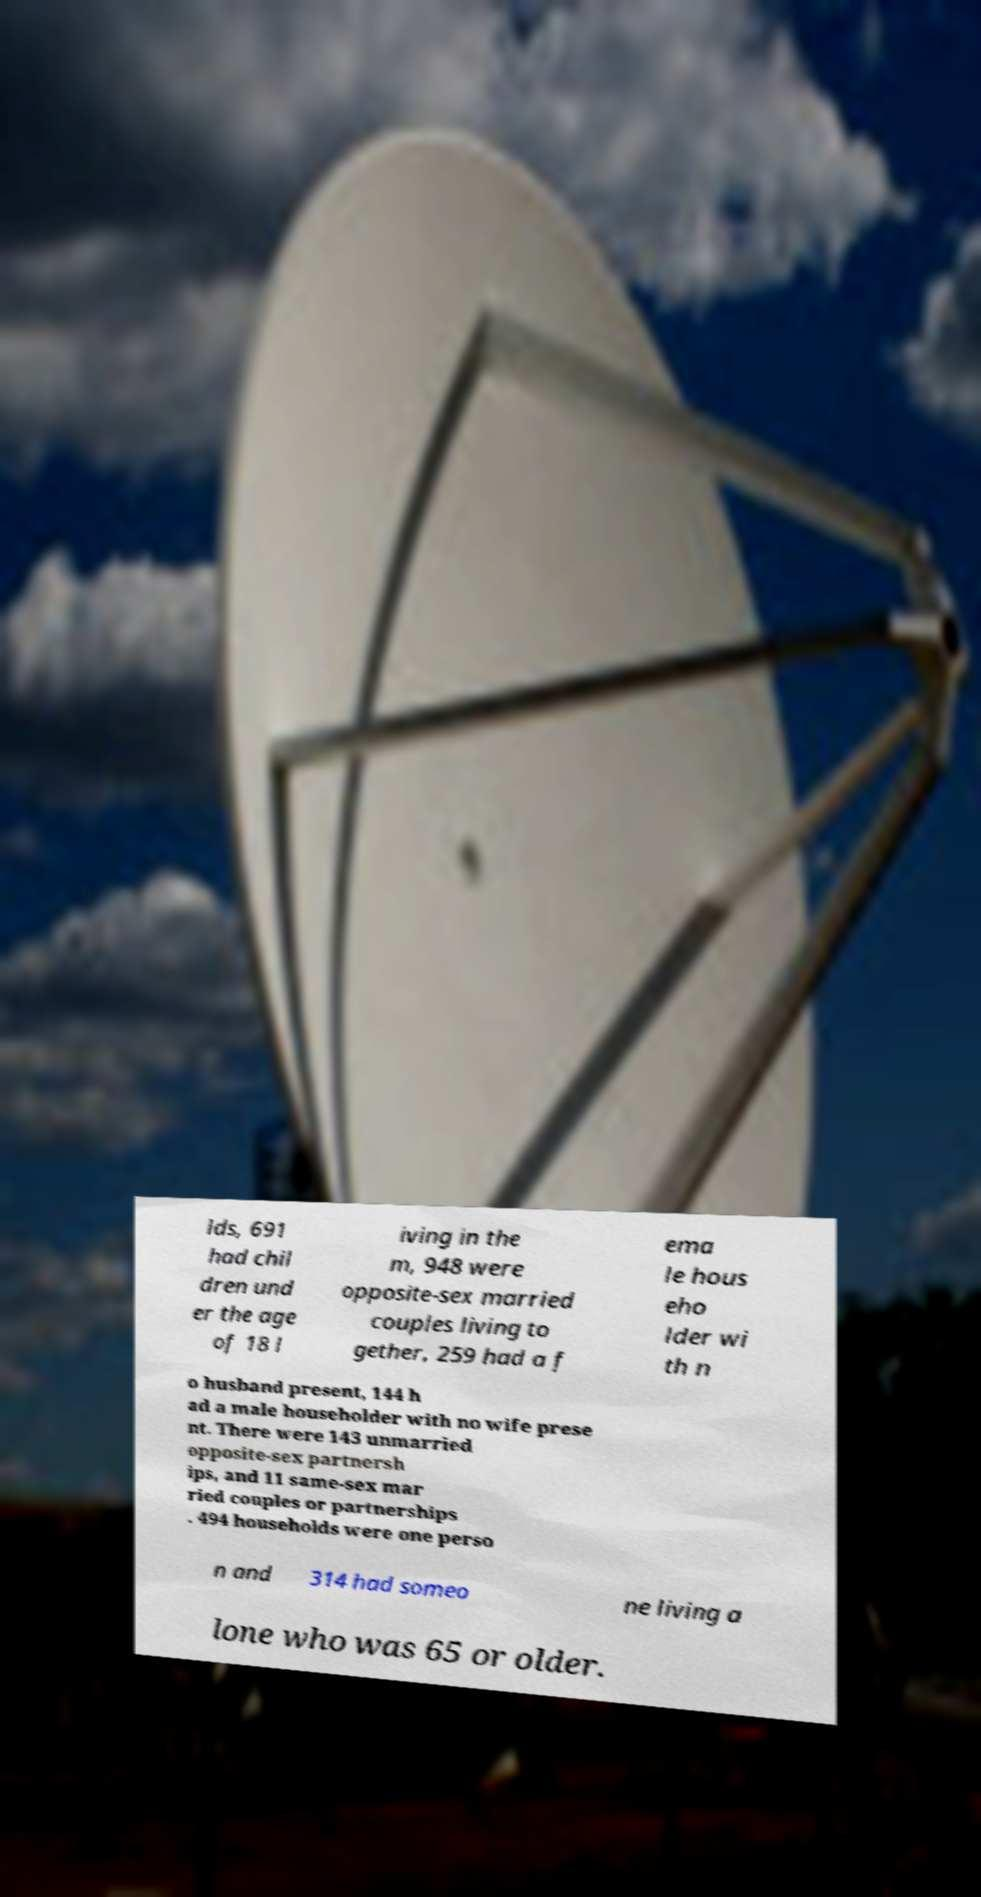What messages or text are displayed in this image? I need them in a readable, typed format. lds, 691 had chil dren und er the age of 18 l iving in the m, 948 were opposite-sex married couples living to gether, 259 had a f ema le hous eho lder wi th n o husband present, 144 h ad a male householder with no wife prese nt. There were 143 unmarried opposite-sex partnersh ips, and 11 same-sex mar ried couples or partnerships . 494 households were one perso n and 314 had someo ne living a lone who was 65 or older. 